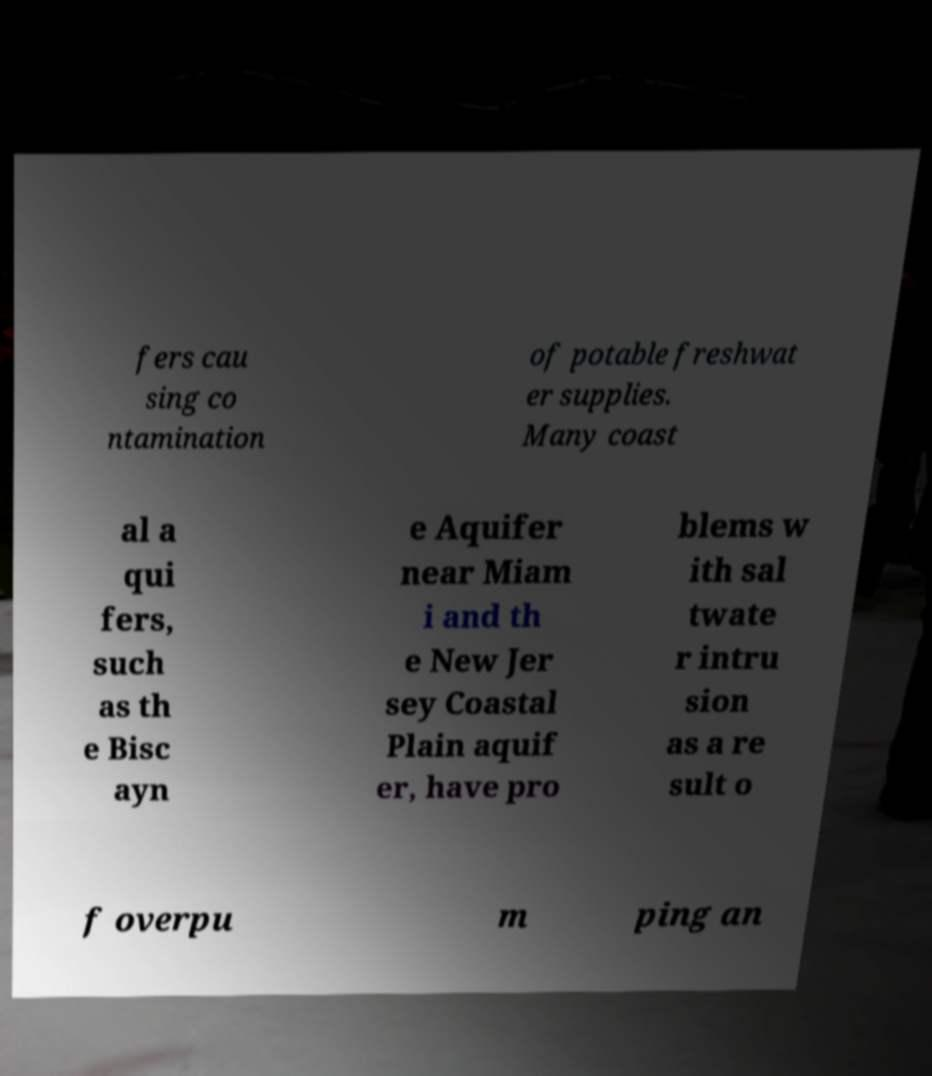For documentation purposes, I need the text within this image transcribed. Could you provide that? fers cau sing co ntamination of potable freshwat er supplies. Many coast al a qui fers, such as th e Bisc ayn e Aquifer near Miam i and th e New Jer sey Coastal Plain aquif er, have pro blems w ith sal twate r intru sion as a re sult o f overpu m ping an 